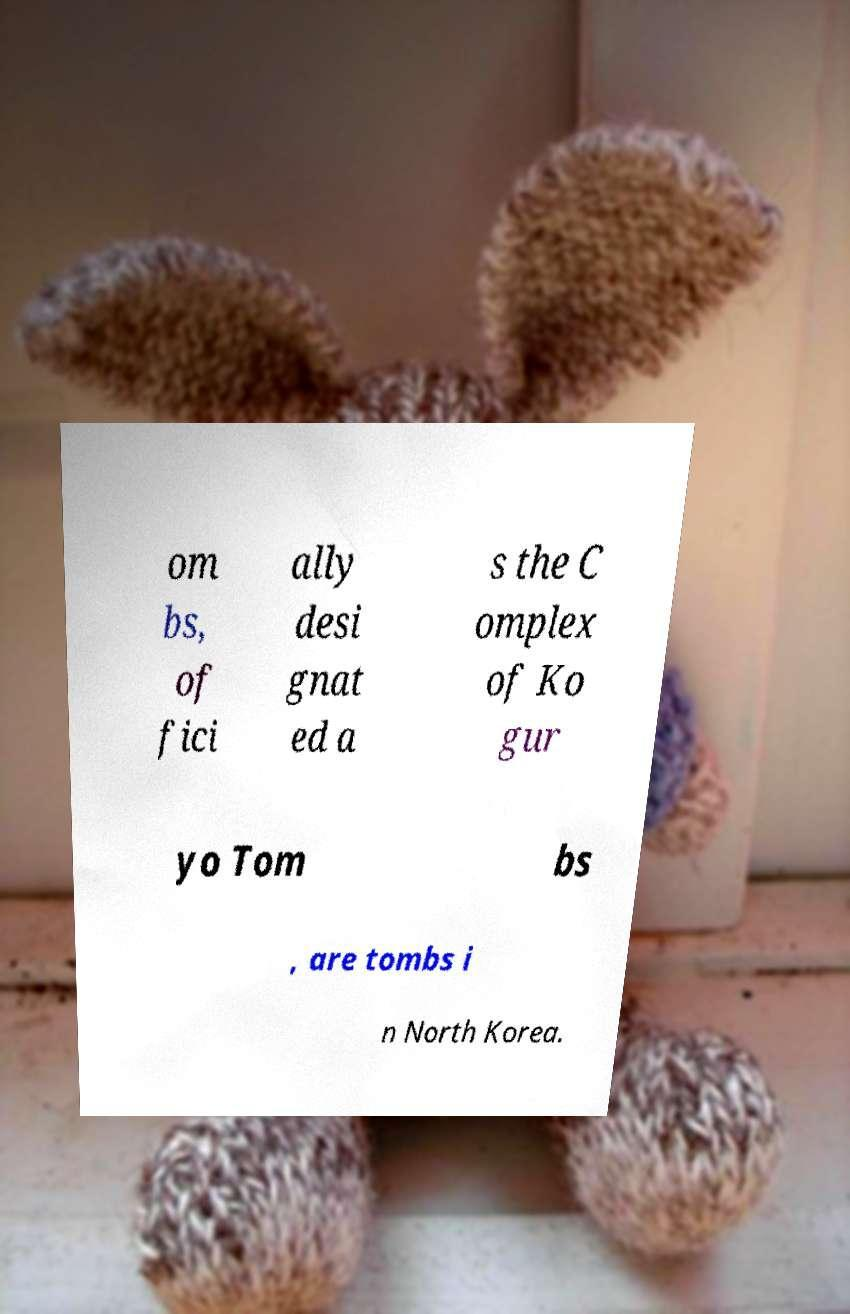I need the written content from this picture converted into text. Can you do that? om bs, of fici ally desi gnat ed a s the C omplex of Ko gur yo Tom bs , are tombs i n North Korea. 